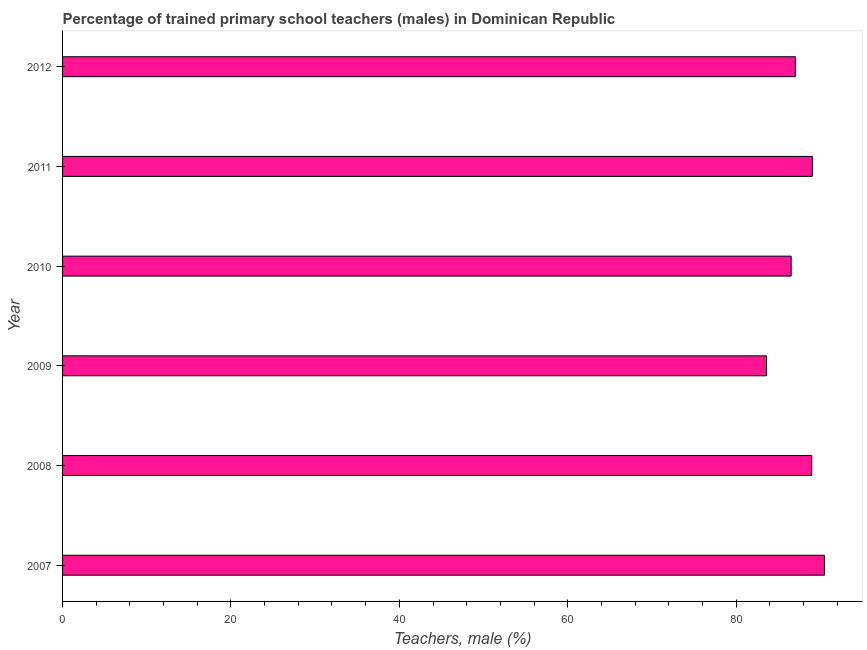Does the graph contain any zero values?
Your answer should be compact. No. Does the graph contain grids?
Give a very brief answer. No. What is the title of the graph?
Offer a terse response. Percentage of trained primary school teachers (males) in Dominican Republic. What is the label or title of the X-axis?
Provide a succinct answer. Teachers, male (%). What is the percentage of trained male teachers in 2008?
Provide a succinct answer. 88.98. Across all years, what is the maximum percentage of trained male teachers?
Your answer should be compact. 90.49. Across all years, what is the minimum percentage of trained male teachers?
Your response must be concise. 83.61. In which year was the percentage of trained male teachers minimum?
Your response must be concise. 2009. What is the sum of the percentage of trained male teachers?
Make the answer very short. 525.71. What is the difference between the percentage of trained male teachers in 2007 and 2009?
Offer a terse response. 6.88. What is the average percentage of trained male teachers per year?
Your answer should be very brief. 87.62. What is the median percentage of trained male teachers?
Make the answer very short. 88.01. In how many years, is the percentage of trained male teachers greater than 68 %?
Give a very brief answer. 6. Do a majority of the years between 2008 and 2009 (inclusive) have percentage of trained male teachers greater than 36 %?
Your answer should be compact. Yes. Is the percentage of trained male teachers in 2009 less than that in 2011?
Offer a terse response. Yes. Is the difference between the percentage of trained male teachers in 2010 and 2011 greater than the difference between any two years?
Give a very brief answer. No. What is the difference between the highest and the second highest percentage of trained male teachers?
Give a very brief answer. 1.43. What is the difference between the highest and the lowest percentage of trained male teachers?
Keep it short and to the point. 6.87. In how many years, is the percentage of trained male teachers greater than the average percentage of trained male teachers taken over all years?
Provide a short and direct response. 3. How many bars are there?
Your answer should be very brief. 6. Are all the bars in the graph horizontal?
Provide a short and direct response. Yes. How many years are there in the graph?
Your answer should be very brief. 6. Are the values on the major ticks of X-axis written in scientific E-notation?
Your answer should be compact. No. What is the Teachers, male (%) of 2007?
Your answer should be compact. 90.49. What is the Teachers, male (%) in 2008?
Your answer should be very brief. 88.98. What is the Teachers, male (%) of 2009?
Ensure brevity in your answer.  83.61. What is the Teachers, male (%) of 2010?
Provide a succinct answer. 86.54. What is the Teachers, male (%) in 2011?
Keep it short and to the point. 89.06. What is the Teachers, male (%) of 2012?
Your answer should be very brief. 87.04. What is the difference between the Teachers, male (%) in 2007 and 2008?
Ensure brevity in your answer.  1.51. What is the difference between the Teachers, male (%) in 2007 and 2009?
Keep it short and to the point. 6.87. What is the difference between the Teachers, male (%) in 2007 and 2010?
Offer a terse response. 3.95. What is the difference between the Teachers, male (%) in 2007 and 2011?
Your answer should be compact. 1.43. What is the difference between the Teachers, male (%) in 2007 and 2012?
Your response must be concise. 3.45. What is the difference between the Teachers, male (%) in 2008 and 2009?
Provide a succinct answer. 5.37. What is the difference between the Teachers, male (%) in 2008 and 2010?
Provide a short and direct response. 2.44. What is the difference between the Teachers, male (%) in 2008 and 2011?
Provide a succinct answer. -0.08. What is the difference between the Teachers, male (%) in 2008 and 2012?
Offer a very short reply. 1.94. What is the difference between the Teachers, male (%) in 2009 and 2010?
Your answer should be compact. -2.93. What is the difference between the Teachers, male (%) in 2009 and 2011?
Offer a terse response. -5.45. What is the difference between the Teachers, male (%) in 2009 and 2012?
Offer a very short reply. -3.43. What is the difference between the Teachers, male (%) in 2010 and 2011?
Ensure brevity in your answer.  -2.52. What is the difference between the Teachers, male (%) in 2010 and 2012?
Ensure brevity in your answer.  -0.5. What is the difference between the Teachers, male (%) in 2011 and 2012?
Your answer should be very brief. 2.02. What is the ratio of the Teachers, male (%) in 2007 to that in 2009?
Offer a very short reply. 1.08. What is the ratio of the Teachers, male (%) in 2007 to that in 2010?
Offer a terse response. 1.05. What is the ratio of the Teachers, male (%) in 2008 to that in 2009?
Make the answer very short. 1.06. What is the ratio of the Teachers, male (%) in 2008 to that in 2010?
Offer a very short reply. 1.03. What is the ratio of the Teachers, male (%) in 2008 to that in 2011?
Ensure brevity in your answer.  1. What is the ratio of the Teachers, male (%) in 2009 to that in 2011?
Your answer should be very brief. 0.94. What is the ratio of the Teachers, male (%) in 2009 to that in 2012?
Offer a very short reply. 0.96. What is the ratio of the Teachers, male (%) in 2011 to that in 2012?
Make the answer very short. 1.02. 